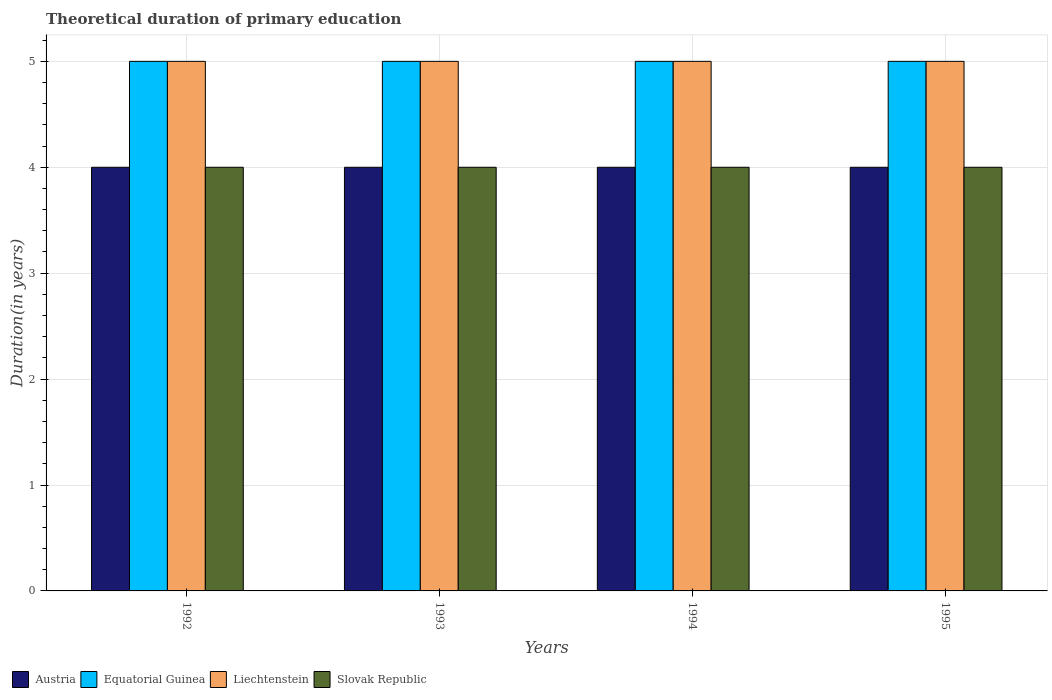How many different coloured bars are there?
Ensure brevity in your answer.  4. How many groups of bars are there?
Your answer should be very brief. 4. How many bars are there on the 3rd tick from the right?
Offer a very short reply. 4. What is the label of the 4th group of bars from the left?
Offer a terse response. 1995. In how many cases, is the number of bars for a given year not equal to the number of legend labels?
Make the answer very short. 0. What is the total theoretical duration of primary education in Austria in 1995?
Provide a succinct answer. 4. Across all years, what is the maximum total theoretical duration of primary education in Austria?
Your response must be concise. 4. Across all years, what is the minimum total theoretical duration of primary education in Equatorial Guinea?
Your answer should be compact. 5. What is the total total theoretical duration of primary education in Liechtenstein in the graph?
Ensure brevity in your answer.  20. What is the difference between the total theoretical duration of primary education in Equatorial Guinea in 1993 and the total theoretical duration of primary education in Austria in 1995?
Give a very brief answer. 1. What is the average total theoretical duration of primary education in Liechtenstein per year?
Offer a very short reply. 5. In the year 1993, what is the difference between the total theoretical duration of primary education in Slovak Republic and total theoretical duration of primary education in Equatorial Guinea?
Ensure brevity in your answer.  -1. In how many years, is the total theoretical duration of primary education in Slovak Republic greater than 3.6 years?
Provide a short and direct response. 4. What is the ratio of the total theoretical duration of primary education in Liechtenstein in 1994 to that in 1995?
Your answer should be very brief. 1. Is the total theoretical duration of primary education in Liechtenstein in 1993 less than that in 1995?
Give a very brief answer. No. In how many years, is the total theoretical duration of primary education in Slovak Republic greater than the average total theoretical duration of primary education in Slovak Republic taken over all years?
Your response must be concise. 0. Is the sum of the total theoretical duration of primary education in Equatorial Guinea in 1992 and 1994 greater than the maximum total theoretical duration of primary education in Liechtenstein across all years?
Your answer should be very brief. Yes. Is it the case that in every year, the sum of the total theoretical duration of primary education in Equatorial Guinea and total theoretical duration of primary education in Liechtenstein is greater than the sum of total theoretical duration of primary education in Austria and total theoretical duration of primary education in Slovak Republic?
Your response must be concise. No. What does the 4th bar from the left in 1993 represents?
Your answer should be compact. Slovak Republic. What does the 3rd bar from the right in 1995 represents?
Your response must be concise. Equatorial Guinea. How many years are there in the graph?
Make the answer very short. 4. Are the values on the major ticks of Y-axis written in scientific E-notation?
Keep it short and to the point. No. Does the graph contain any zero values?
Provide a succinct answer. No. Does the graph contain grids?
Ensure brevity in your answer.  Yes. Where does the legend appear in the graph?
Keep it short and to the point. Bottom left. How many legend labels are there?
Your answer should be compact. 4. How are the legend labels stacked?
Offer a very short reply. Horizontal. What is the title of the graph?
Your answer should be compact. Theoretical duration of primary education. Does "Serbia" appear as one of the legend labels in the graph?
Provide a short and direct response. No. What is the label or title of the X-axis?
Provide a succinct answer. Years. What is the label or title of the Y-axis?
Give a very brief answer. Duration(in years). What is the Duration(in years) of Liechtenstein in 1992?
Provide a short and direct response. 5. What is the Duration(in years) of Austria in 1993?
Your answer should be very brief. 4. What is the Duration(in years) in Liechtenstein in 1993?
Offer a very short reply. 5. What is the Duration(in years) of Austria in 1994?
Keep it short and to the point. 4. What is the Duration(in years) of Liechtenstein in 1994?
Provide a short and direct response. 5. What is the Duration(in years) of Equatorial Guinea in 1995?
Provide a short and direct response. 5. What is the Duration(in years) of Liechtenstein in 1995?
Provide a short and direct response. 5. What is the Duration(in years) of Slovak Republic in 1995?
Ensure brevity in your answer.  4. Across all years, what is the maximum Duration(in years) of Liechtenstein?
Keep it short and to the point. 5. Across all years, what is the minimum Duration(in years) in Austria?
Your answer should be very brief. 4. Across all years, what is the minimum Duration(in years) of Liechtenstein?
Offer a terse response. 5. What is the total Duration(in years) in Equatorial Guinea in the graph?
Make the answer very short. 20. What is the total Duration(in years) of Slovak Republic in the graph?
Give a very brief answer. 16. What is the difference between the Duration(in years) of Equatorial Guinea in 1992 and that in 1993?
Keep it short and to the point. 0. What is the difference between the Duration(in years) in Liechtenstein in 1992 and that in 1994?
Give a very brief answer. 0. What is the difference between the Duration(in years) of Equatorial Guinea in 1992 and that in 1995?
Provide a succinct answer. 0. What is the difference between the Duration(in years) in Liechtenstein in 1992 and that in 1995?
Provide a short and direct response. 0. What is the difference between the Duration(in years) in Liechtenstein in 1993 and that in 1994?
Give a very brief answer. 0. What is the difference between the Duration(in years) in Slovak Republic in 1993 and that in 1994?
Your answer should be very brief. 0. What is the difference between the Duration(in years) in Austria in 1993 and that in 1995?
Your answer should be compact. 0. What is the difference between the Duration(in years) in Slovak Republic in 1993 and that in 1995?
Ensure brevity in your answer.  0. What is the difference between the Duration(in years) in Equatorial Guinea in 1994 and that in 1995?
Your response must be concise. 0. What is the difference between the Duration(in years) of Austria in 1992 and the Duration(in years) of Equatorial Guinea in 1993?
Your answer should be very brief. -1. What is the difference between the Duration(in years) of Austria in 1992 and the Duration(in years) of Slovak Republic in 1993?
Offer a terse response. 0. What is the difference between the Duration(in years) of Equatorial Guinea in 1992 and the Duration(in years) of Slovak Republic in 1993?
Your response must be concise. 1. What is the difference between the Duration(in years) of Austria in 1992 and the Duration(in years) of Liechtenstein in 1994?
Offer a terse response. -1. What is the difference between the Duration(in years) of Austria in 1992 and the Duration(in years) of Slovak Republic in 1994?
Your answer should be compact. 0. What is the difference between the Duration(in years) in Austria in 1992 and the Duration(in years) in Liechtenstein in 1995?
Your answer should be compact. -1. What is the difference between the Duration(in years) of Equatorial Guinea in 1992 and the Duration(in years) of Liechtenstein in 1995?
Your answer should be very brief. 0. What is the difference between the Duration(in years) in Liechtenstein in 1992 and the Duration(in years) in Slovak Republic in 1995?
Offer a terse response. 1. What is the difference between the Duration(in years) in Austria in 1993 and the Duration(in years) in Liechtenstein in 1994?
Give a very brief answer. -1. What is the difference between the Duration(in years) of Austria in 1993 and the Duration(in years) of Liechtenstein in 1995?
Your response must be concise. -1. What is the difference between the Duration(in years) in Austria in 1993 and the Duration(in years) in Slovak Republic in 1995?
Provide a succinct answer. 0. What is the difference between the Duration(in years) of Equatorial Guinea in 1993 and the Duration(in years) of Slovak Republic in 1995?
Keep it short and to the point. 1. What is the difference between the Duration(in years) in Liechtenstein in 1993 and the Duration(in years) in Slovak Republic in 1995?
Keep it short and to the point. 1. What is the difference between the Duration(in years) in Equatorial Guinea in 1994 and the Duration(in years) in Slovak Republic in 1995?
Your answer should be very brief. 1. What is the average Duration(in years) in Liechtenstein per year?
Provide a succinct answer. 5. What is the average Duration(in years) of Slovak Republic per year?
Your answer should be very brief. 4. In the year 1992, what is the difference between the Duration(in years) in Austria and Duration(in years) in Equatorial Guinea?
Ensure brevity in your answer.  -1. In the year 1993, what is the difference between the Duration(in years) of Austria and Duration(in years) of Liechtenstein?
Ensure brevity in your answer.  -1. In the year 1993, what is the difference between the Duration(in years) in Austria and Duration(in years) in Slovak Republic?
Ensure brevity in your answer.  0. In the year 1993, what is the difference between the Duration(in years) of Equatorial Guinea and Duration(in years) of Slovak Republic?
Provide a succinct answer. 1. In the year 1993, what is the difference between the Duration(in years) of Liechtenstein and Duration(in years) of Slovak Republic?
Provide a succinct answer. 1. In the year 1994, what is the difference between the Duration(in years) of Austria and Duration(in years) of Slovak Republic?
Your response must be concise. 0. In the year 1994, what is the difference between the Duration(in years) of Equatorial Guinea and Duration(in years) of Slovak Republic?
Offer a terse response. 1. In the year 1994, what is the difference between the Duration(in years) of Liechtenstein and Duration(in years) of Slovak Republic?
Provide a succinct answer. 1. In the year 1995, what is the difference between the Duration(in years) of Austria and Duration(in years) of Slovak Republic?
Keep it short and to the point. 0. In the year 1995, what is the difference between the Duration(in years) in Equatorial Guinea and Duration(in years) in Liechtenstein?
Offer a terse response. 0. In the year 1995, what is the difference between the Duration(in years) of Equatorial Guinea and Duration(in years) of Slovak Republic?
Provide a succinct answer. 1. In the year 1995, what is the difference between the Duration(in years) in Liechtenstein and Duration(in years) in Slovak Republic?
Give a very brief answer. 1. What is the ratio of the Duration(in years) of Liechtenstein in 1992 to that in 1993?
Your response must be concise. 1. What is the ratio of the Duration(in years) of Slovak Republic in 1992 to that in 1993?
Your answer should be very brief. 1. What is the ratio of the Duration(in years) of Slovak Republic in 1992 to that in 1994?
Ensure brevity in your answer.  1. What is the ratio of the Duration(in years) of Slovak Republic in 1992 to that in 1995?
Your answer should be very brief. 1. What is the ratio of the Duration(in years) in Equatorial Guinea in 1993 to that in 1994?
Offer a very short reply. 1. What is the ratio of the Duration(in years) in Slovak Republic in 1993 to that in 1994?
Keep it short and to the point. 1. What is the ratio of the Duration(in years) of Liechtenstein in 1993 to that in 1995?
Make the answer very short. 1. What is the ratio of the Duration(in years) in Austria in 1994 to that in 1995?
Make the answer very short. 1. What is the ratio of the Duration(in years) of Liechtenstein in 1994 to that in 1995?
Provide a short and direct response. 1. What is the difference between the highest and the second highest Duration(in years) of Austria?
Offer a very short reply. 0. What is the difference between the highest and the second highest Duration(in years) of Equatorial Guinea?
Ensure brevity in your answer.  0. What is the difference between the highest and the second highest Duration(in years) of Slovak Republic?
Make the answer very short. 0. What is the difference between the highest and the lowest Duration(in years) of Equatorial Guinea?
Your response must be concise. 0. 